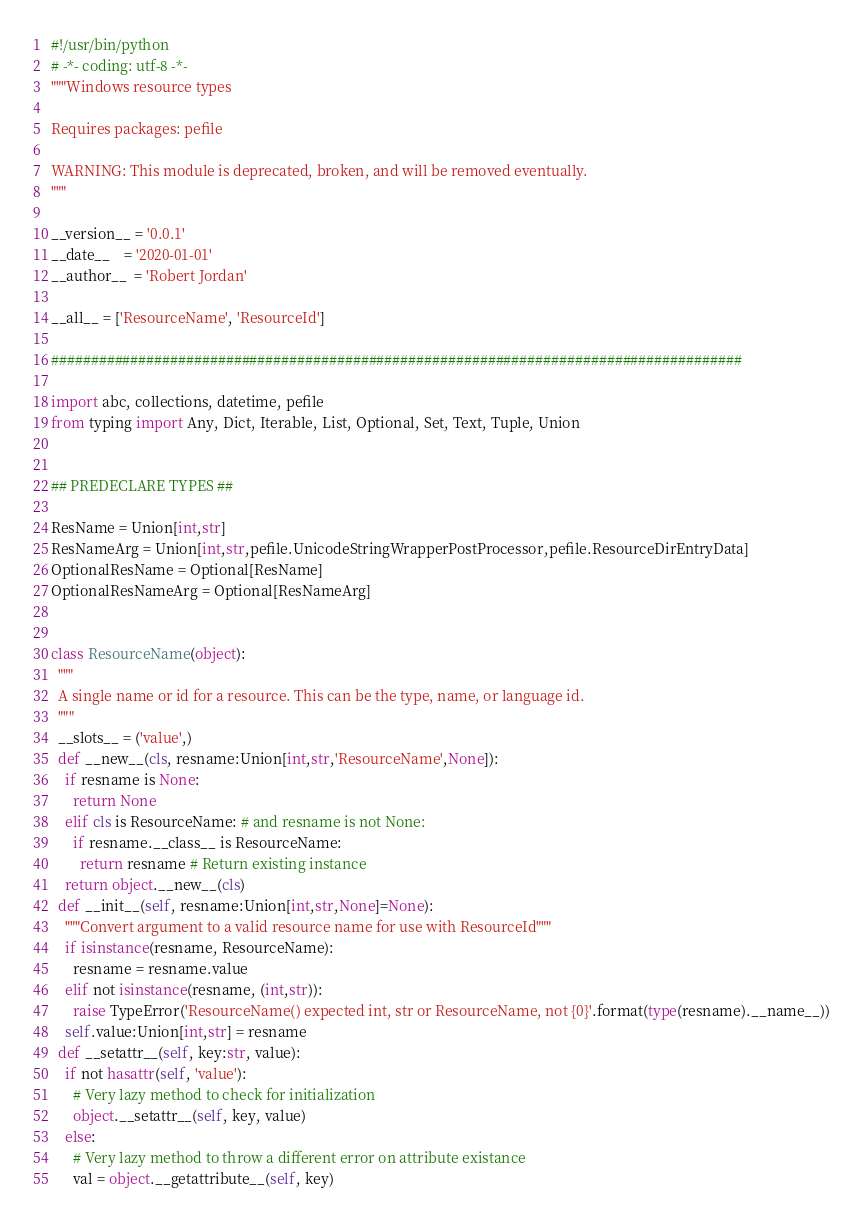Convert code to text. <code><loc_0><loc_0><loc_500><loc_500><_Python_>#!/usr/bin/python
# -*- coding: utf-8 -*-
"""Windows resource types

Requires packages: pefile

WARNING: This module is deprecated, broken, and will be removed eventually.
"""

__version__ = '0.0.1'
__date__    = '2020-01-01'
__author__  = 'Robert Jordan'

__all__ = ['ResourceName', 'ResourceId']

#######################################################################################

import abc, collections, datetime, pefile
from typing import Any, Dict, Iterable, List, Optional, Set, Text, Tuple, Union


## PREDECLARE TYPES ##

ResName = Union[int,str]
ResNameArg = Union[int,str,pefile.UnicodeStringWrapperPostProcessor,pefile.ResourceDirEntryData]
OptionalResName = Optional[ResName]
OptionalResNameArg = Optional[ResNameArg]


class ResourceName(object):
  """
  A single name or id for a resource. This can be the type, name, or language id.
  """
  __slots__ = ('value',)
  def __new__(cls, resname:Union[int,str,'ResourceName',None]):
    if resname is None:
      return None
    elif cls is ResourceName: # and resname is not None:
      if resname.__class__ is ResourceName:
        return resname # Return existing instance
    return object.__new__(cls)
  def __init__(self, resname:Union[int,str,None]=None):
    """Convert argument to a valid resource name for use with ResourceId"""
    if isinstance(resname, ResourceName):
      resname = resname.value
    elif not isinstance(resname, (int,str)):
      raise TypeError('ResourceName() expected int, str or ResourceName, not {0}'.format(type(resname).__name__))
    self.value:Union[int,str] = resname
  def __setattr__(self, key:str, value):
    if not hasattr(self, 'value'):
      # Very lazy method to check for initialization
      object.__setattr__(self, key, value)
    else:
      # Very lazy method to throw a different error on attribute existance
      val = object.__getattribute__(self, key)</code> 